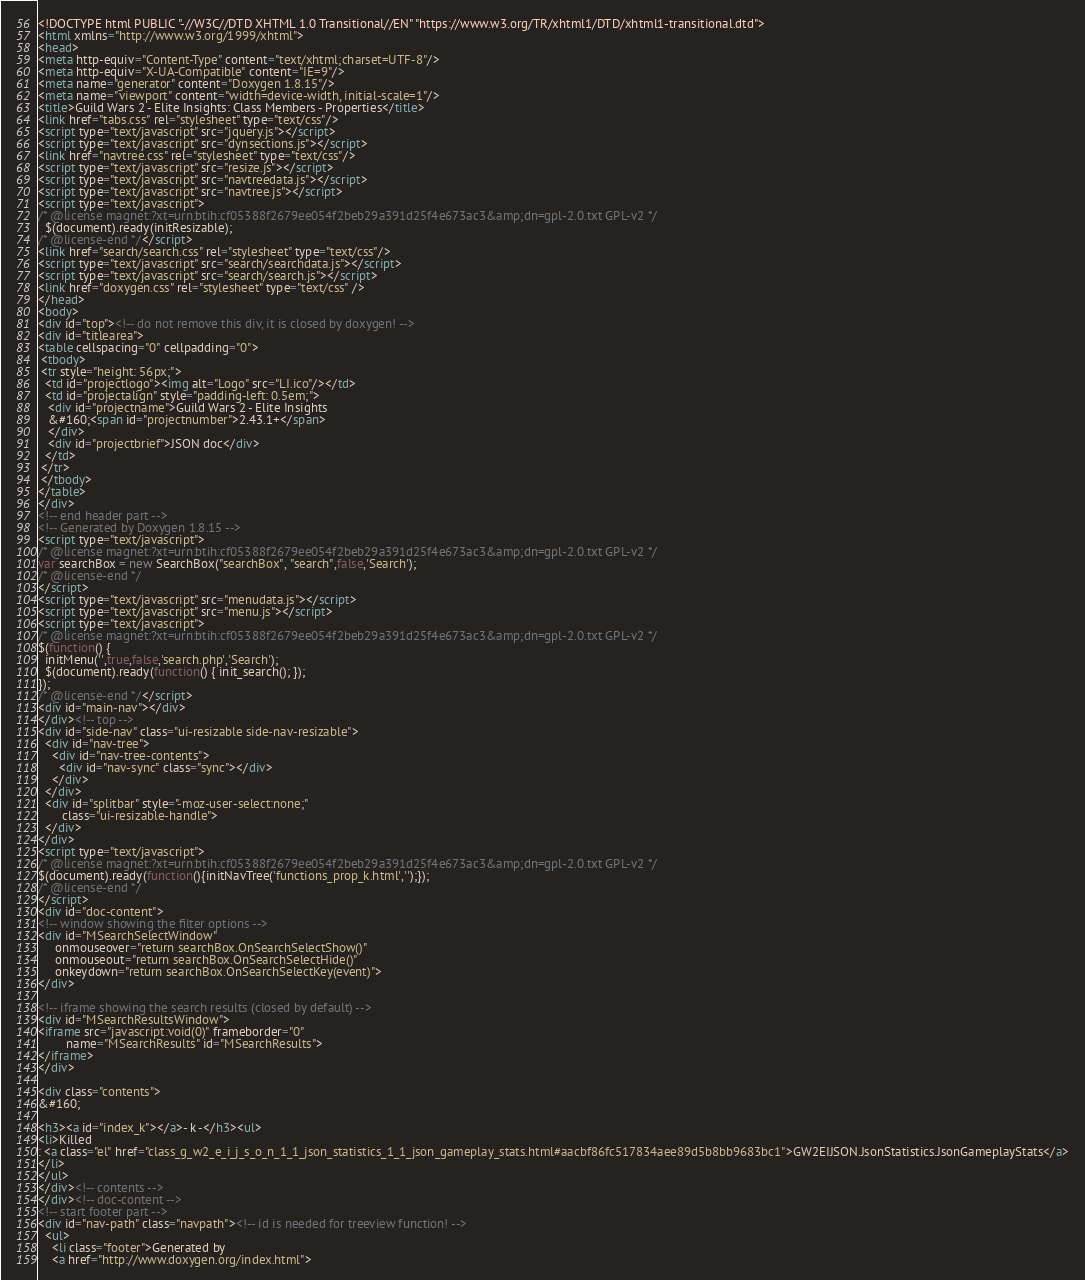Convert code to text. <code><loc_0><loc_0><loc_500><loc_500><_HTML_><!DOCTYPE html PUBLIC "-//W3C//DTD XHTML 1.0 Transitional//EN" "https://www.w3.org/TR/xhtml1/DTD/xhtml1-transitional.dtd">
<html xmlns="http://www.w3.org/1999/xhtml">
<head>
<meta http-equiv="Content-Type" content="text/xhtml;charset=UTF-8"/>
<meta http-equiv="X-UA-Compatible" content="IE=9"/>
<meta name="generator" content="Doxygen 1.8.15"/>
<meta name="viewport" content="width=device-width, initial-scale=1"/>
<title>Guild Wars 2 - Elite Insights: Class Members - Properties</title>
<link href="tabs.css" rel="stylesheet" type="text/css"/>
<script type="text/javascript" src="jquery.js"></script>
<script type="text/javascript" src="dynsections.js"></script>
<link href="navtree.css" rel="stylesheet" type="text/css"/>
<script type="text/javascript" src="resize.js"></script>
<script type="text/javascript" src="navtreedata.js"></script>
<script type="text/javascript" src="navtree.js"></script>
<script type="text/javascript">
/* @license magnet:?xt=urn:btih:cf05388f2679ee054f2beb29a391d25f4e673ac3&amp;dn=gpl-2.0.txt GPL-v2 */
  $(document).ready(initResizable);
/* @license-end */</script>
<link href="search/search.css" rel="stylesheet" type="text/css"/>
<script type="text/javascript" src="search/searchdata.js"></script>
<script type="text/javascript" src="search/search.js"></script>
<link href="doxygen.css" rel="stylesheet" type="text/css" />
</head>
<body>
<div id="top"><!-- do not remove this div, it is closed by doxygen! -->
<div id="titlearea">
<table cellspacing="0" cellpadding="0">
 <tbody>
 <tr style="height: 56px;">
  <td id="projectlogo"><img alt="Logo" src="LI.ico"/></td>
  <td id="projectalign" style="padding-left: 0.5em;">
   <div id="projectname">Guild Wars 2 - Elite Insights
   &#160;<span id="projectnumber">2.43.1+</span>
   </div>
   <div id="projectbrief">JSON doc</div>
  </td>
 </tr>
 </tbody>
</table>
</div>
<!-- end header part -->
<!-- Generated by Doxygen 1.8.15 -->
<script type="text/javascript">
/* @license magnet:?xt=urn:btih:cf05388f2679ee054f2beb29a391d25f4e673ac3&amp;dn=gpl-2.0.txt GPL-v2 */
var searchBox = new SearchBox("searchBox", "search",false,'Search');
/* @license-end */
</script>
<script type="text/javascript" src="menudata.js"></script>
<script type="text/javascript" src="menu.js"></script>
<script type="text/javascript">
/* @license magnet:?xt=urn:btih:cf05388f2679ee054f2beb29a391d25f4e673ac3&amp;dn=gpl-2.0.txt GPL-v2 */
$(function() {
  initMenu('',true,false,'search.php','Search');
  $(document).ready(function() { init_search(); });
});
/* @license-end */</script>
<div id="main-nav"></div>
</div><!-- top -->
<div id="side-nav" class="ui-resizable side-nav-resizable">
  <div id="nav-tree">
    <div id="nav-tree-contents">
      <div id="nav-sync" class="sync"></div>
    </div>
  </div>
  <div id="splitbar" style="-moz-user-select:none;" 
       class="ui-resizable-handle">
  </div>
</div>
<script type="text/javascript">
/* @license magnet:?xt=urn:btih:cf05388f2679ee054f2beb29a391d25f4e673ac3&amp;dn=gpl-2.0.txt GPL-v2 */
$(document).ready(function(){initNavTree('functions_prop_k.html','');});
/* @license-end */
</script>
<div id="doc-content">
<!-- window showing the filter options -->
<div id="MSearchSelectWindow"
     onmouseover="return searchBox.OnSearchSelectShow()"
     onmouseout="return searchBox.OnSearchSelectHide()"
     onkeydown="return searchBox.OnSearchSelectKey(event)">
</div>

<!-- iframe showing the search results (closed by default) -->
<div id="MSearchResultsWindow">
<iframe src="javascript:void(0)" frameborder="0" 
        name="MSearchResults" id="MSearchResults">
</iframe>
</div>

<div class="contents">
&#160;

<h3><a id="index_k"></a>- k -</h3><ul>
<li>Killed
: <a class="el" href="class_g_w2_e_i_j_s_o_n_1_1_json_statistics_1_1_json_gameplay_stats.html#aacbf86fc517834aee89d5b8bb9683bc1">GW2EIJSON.JsonStatistics.JsonGameplayStats</a>
</li>
</ul>
</div><!-- contents -->
</div><!-- doc-content -->
<!-- start footer part -->
<div id="nav-path" class="navpath"><!-- id is needed for treeview function! -->
  <ul>
    <li class="footer">Generated by
    <a href="http://www.doxygen.org/index.html"></code> 